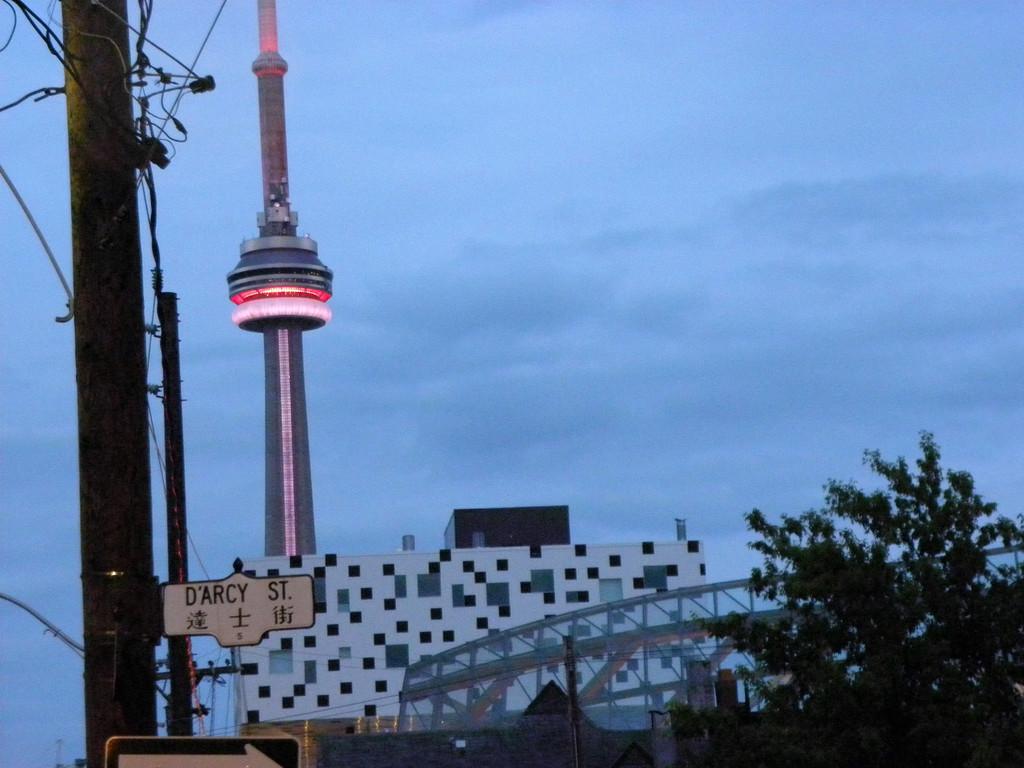How would you summarize this image in a sentence or two? In the image we can see the building, pole, tower, electric wires, trees and the cloudy sky. We can even see the board and text on it. 